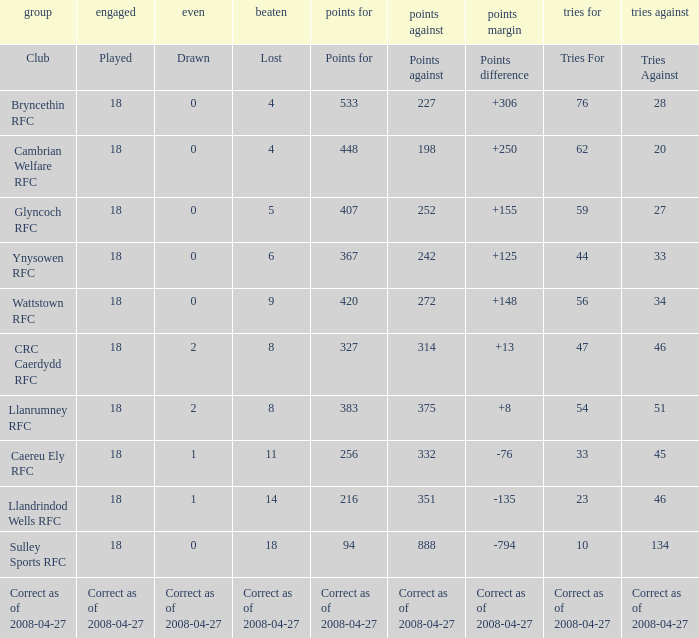What is the value for the item "Lost" when the value "Tries" is 47? 8.0. 